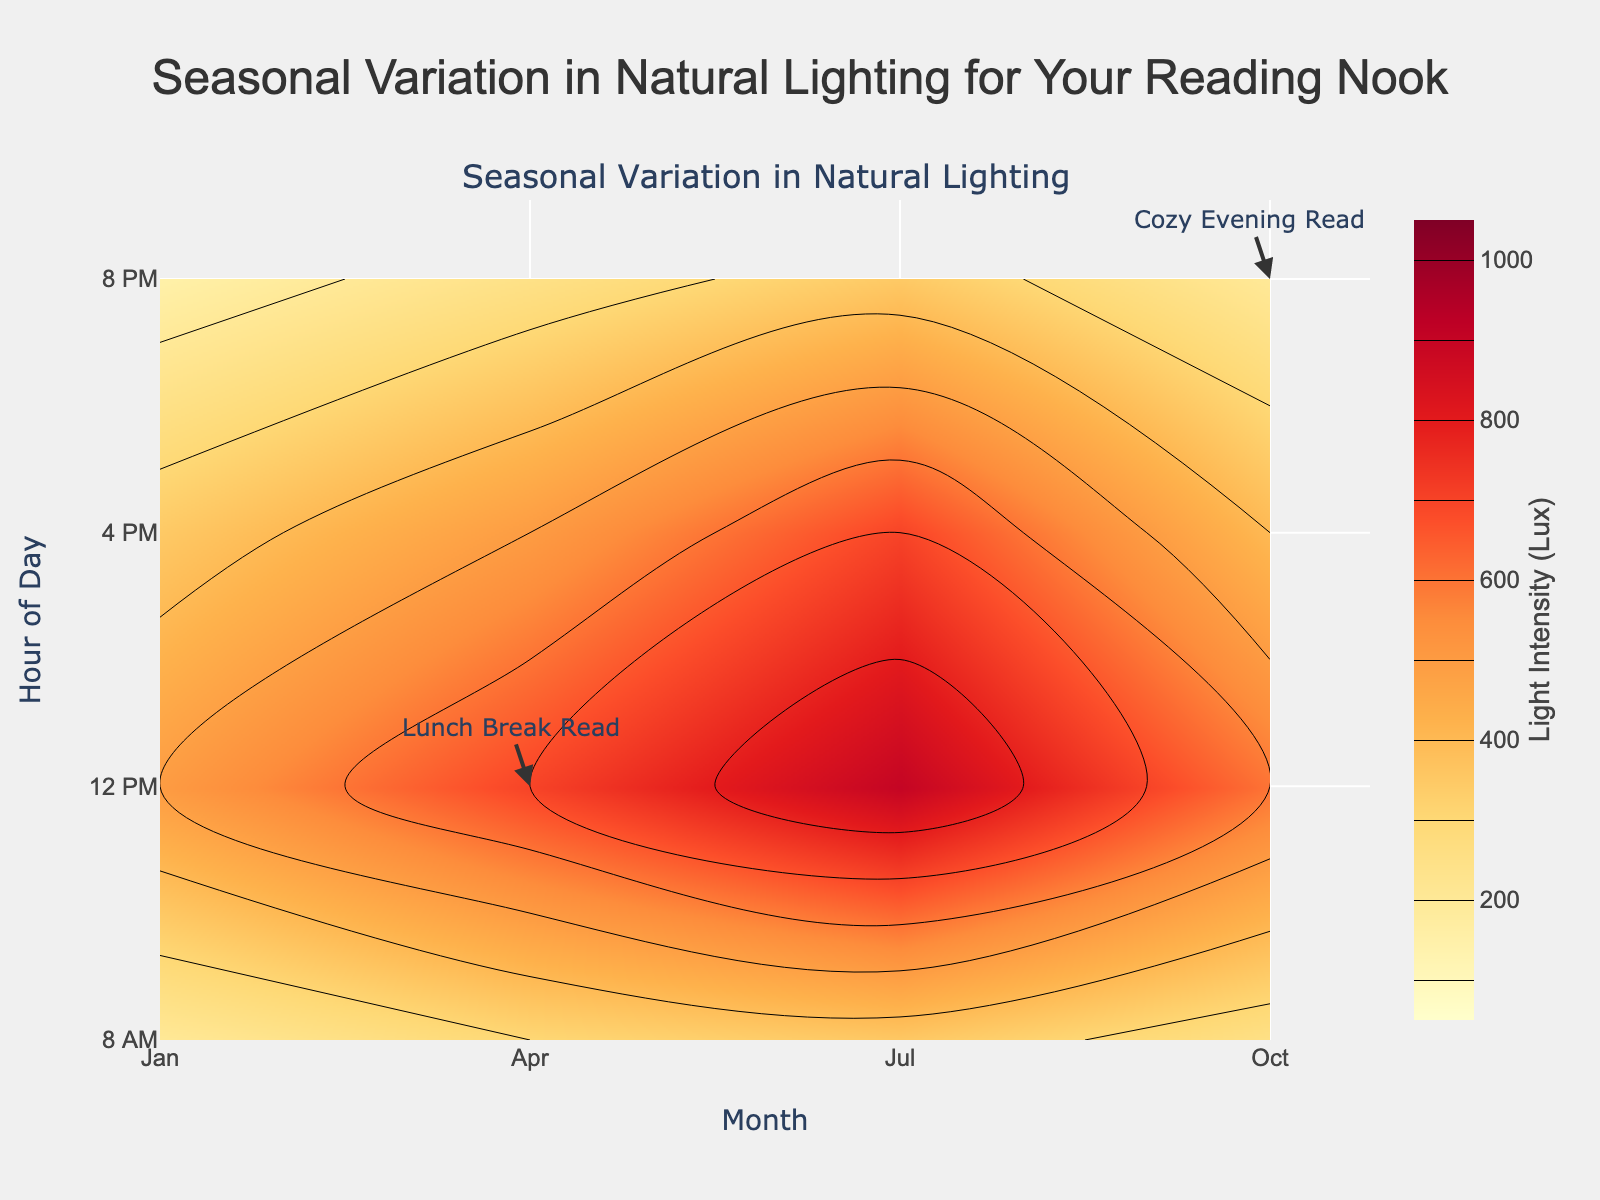What is the title of the plot? The title is located at the top of the figure and provides an overview of the content. In this case, it's prominently displayed in larger font size and centered at the top.
Answer: Seasonal Variation in Natural Lighting for Your Reading Nook In which month does the light intensity peak at 12 PM? Look at the x-axis label for "Month" and the y-axis label for "Hour of Day". Find the point where they intersect at 12 PM (y-axis) and see the color/intensity level for each month on the x-axis. Identify the month with the highest intensity.
Answer: July What hour has the highest light intensity in October? Examine the contour plot focusing on October. Follow the October column downward (Month = 10) and observe the heatmap colors at different hours to identify the peak intensity.
Answer: 12 PM Which month has the least light intensity at 8 AM? Check the contour plot's 8 AM row (y-axis = 8). Compare the light intensity across different months along this row.
Answer: January How much does the light intensity change from 8 AM to 12 PM in April? Find the light intensity at 8 AM and 12 PM for April on the contour plot. Subtract the 8 AM value from the 12 PM value. This requires interpreting the color scale correctly.
Answer: 400 Lux During which hours is the "Prime Reading Time" annotation placed? Locate the annotation labeled "Prime Reading Time" on the plot. Note the position in relation to the y-axis (Hour of Day).
Answer: 4 PM What is the general trend of light intensity from morning (8 AM) to evening (8 PM) across all seasons? Observe the color gradient in each month's column from 8 AM to 8 PM, noting any general increase, peak, or decrease in intensity. Interpret these variations across the entire chart.
Answer: Increases to mid-day then decreases Compare the light intensity at 4 PM in January and July. Which is higher? Look down the January and July columns to the 4 PM row (y-axis = 16). Compare the color contours (intensity levels) between these two points.
Answer: July What pattern can you observe between the annotations and the light intensity? Review each annotation's location related to the contour plot's intensity levels. Check if annotations are placed where the intensity is high or low, and note any specific patterns related to reading preferences.
Answer: Annotations correspond to moderate or higher intensity Is 12 PM always the brightest hour of the day regardless of the month? Examine the 12 PM row (y-axis = 12) across all months. Compare the light intensity levels (color variations) for each month at this hour.
Answer: Yes, generally 